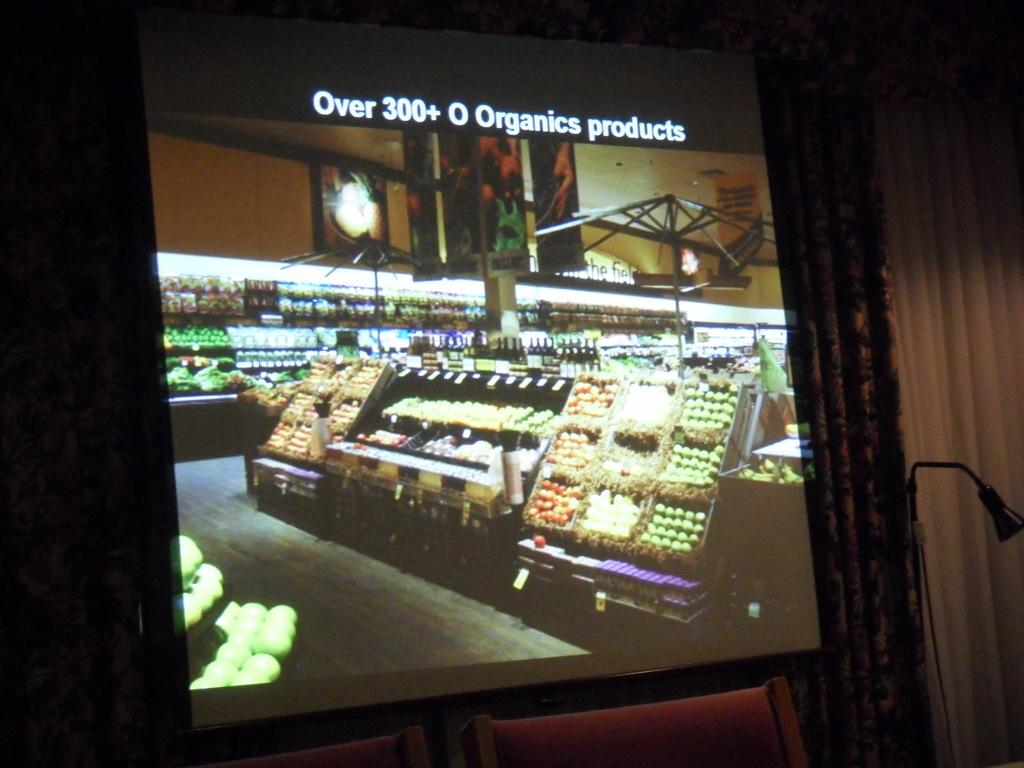<image>
Provide a brief description of the given image. A large projector screen shows a grocery store and says Over 300+ O Organic products. 